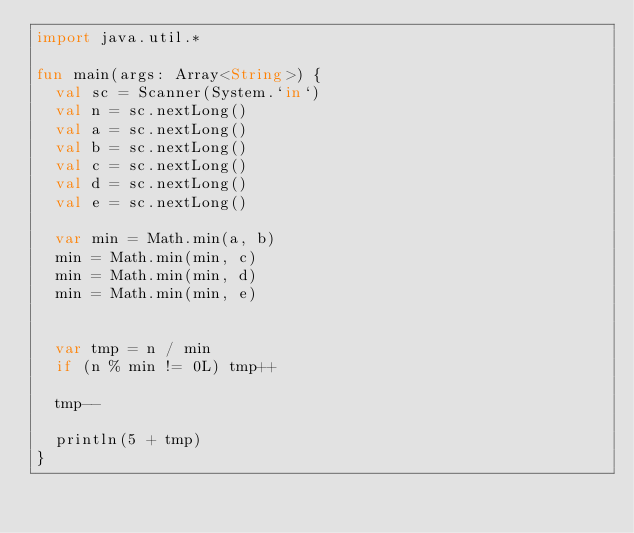Convert code to text. <code><loc_0><loc_0><loc_500><loc_500><_Kotlin_>import java.util.*

fun main(args: Array<String>) {
  val sc = Scanner(System.`in`)
  val n = sc.nextLong()
  val a = sc.nextLong()
  val b = sc.nextLong()
  val c = sc.nextLong()
  val d = sc.nextLong()
  val e = sc.nextLong()

  var min = Math.min(a, b)
  min = Math.min(min, c)
  min = Math.min(min, d)
  min = Math.min(min, e)


  var tmp = n / min
  if (n % min != 0L) tmp++

  tmp--

  println(5 + tmp)
}
</code> 